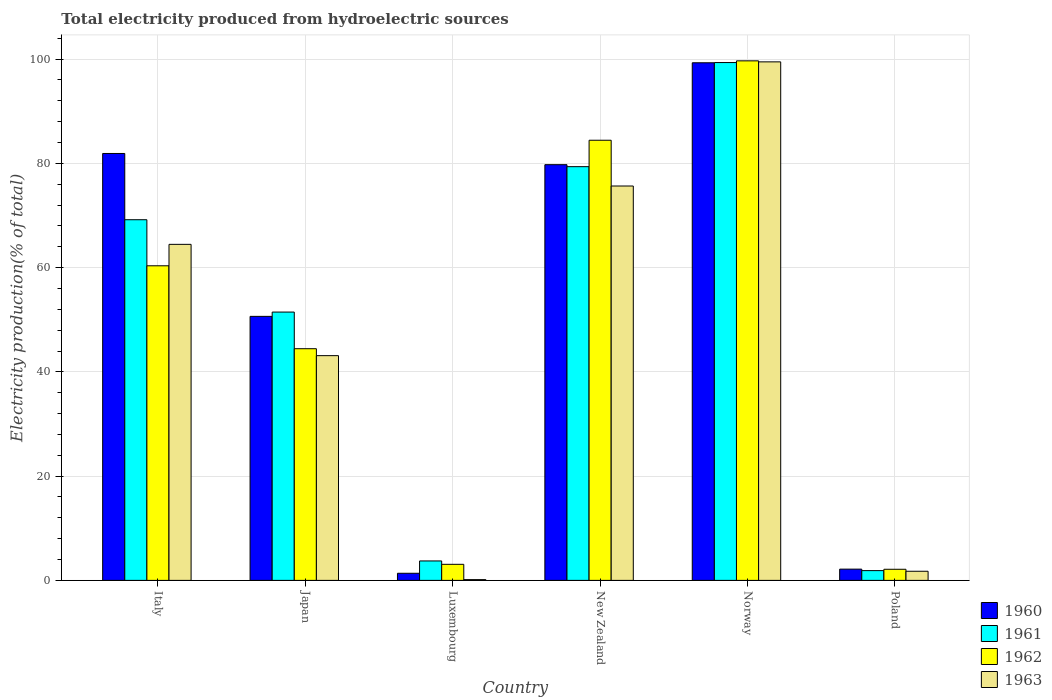How many different coloured bars are there?
Make the answer very short. 4. Are the number of bars per tick equal to the number of legend labels?
Your answer should be compact. Yes. How many bars are there on the 6th tick from the left?
Your response must be concise. 4. What is the label of the 6th group of bars from the left?
Offer a very short reply. Poland. What is the total electricity produced in 1960 in Japan?
Your answer should be very brief. 50.65. Across all countries, what is the maximum total electricity produced in 1961?
Offer a terse response. 99.34. Across all countries, what is the minimum total electricity produced in 1961?
Keep it short and to the point. 1.87. In which country was the total electricity produced in 1961 maximum?
Your answer should be compact. Norway. In which country was the total electricity produced in 1963 minimum?
Your answer should be compact. Luxembourg. What is the total total electricity produced in 1961 in the graph?
Your response must be concise. 304.98. What is the difference between the total electricity produced in 1962 in Japan and that in New Zealand?
Offer a very short reply. -39.99. What is the difference between the total electricity produced in 1960 in Luxembourg and the total electricity produced in 1962 in New Zealand?
Keep it short and to the point. -83.07. What is the average total electricity produced in 1963 per country?
Keep it short and to the point. 47.44. What is the difference between the total electricity produced of/in 1960 and total electricity produced of/in 1962 in Italy?
Offer a very short reply. 21.55. In how many countries, is the total electricity produced in 1962 greater than 88 %?
Keep it short and to the point. 1. What is the ratio of the total electricity produced in 1963 in Luxembourg to that in Norway?
Your response must be concise. 0. Is the total electricity produced in 1962 in Luxembourg less than that in Poland?
Offer a very short reply. No. Is the difference between the total electricity produced in 1960 in Luxembourg and Norway greater than the difference between the total electricity produced in 1962 in Luxembourg and Norway?
Offer a terse response. No. What is the difference between the highest and the second highest total electricity produced in 1962?
Ensure brevity in your answer.  15.23. What is the difference between the highest and the lowest total electricity produced in 1963?
Your answer should be very brief. 99.33. In how many countries, is the total electricity produced in 1962 greater than the average total electricity produced in 1962 taken over all countries?
Offer a terse response. 3. Is the sum of the total electricity produced in 1962 in Luxembourg and Poland greater than the maximum total electricity produced in 1961 across all countries?
Ensure brevity in your answer.  No. What does the 4th bar from the left in Italy represents?
Your answer should be compact. 1963. What does the 2nd bar from the right in New Zealand represents?
Your answer should be compact. 1962. Are all the bars in the graph horizontal?
Give a very brief answer. No. How many countries are there in the graph?
Your answer should be compact. 6. What is the difference between two consecutive major ticks on the Y-axis?
Offer a very short reply. 20. Are the values on the major ticks of Y-axis written in scientific E-notation?
Offer a terse response. No. Where does the legend appear in the graph?
Keep it short and to the point. Bottom right. What is the title of the graph?
Provide a short and direct response. Total electricity produced from hydroelectric sources. What is the label or title of the X-axis?
Provide a succinct answer. Country. What is the Electricity production(% of total) in 1960 in Italy?
Your answer should be very brief. 81.9. What is the Electricity production(% of total) of 1961 in Italy?
Provide a succinct answer. 69.19. What is the Electricity production(% of total) of 1962 in Italy?
Your response must be concise. 60.35. What is the Electricity production(% of total) in 1963 in Italy?
Your answer should be compact. 64.47. What is the Electricity production(% of total) of 1960 in Japan?
Ensure brevity in your answer.  50.65. What is the Electricity production(% of total) in 1961 in Japan?
Provide a short and direct response. 51.48. What is the Electricity production(% of total) of 1962 in Japan?
Make the answer very short. 44.44. What is the Electricity production(% of total) in 1963 in Japan?
Keep it short and to the point. 43.11. What is the Electricity production(% of total) in 1960 in Luxembourg?
Your response must be concise. 1.37. What is the Electricity production(% of total) in 1961 in Luxembourg?
Your answer should be compact. 3.73. What is the Electricity production(% of total) of 1962 in Luxembourg?
Your answer should be very brief. 3.08. What is the Electricity production(% of total) of 1963 in Luxembourg?
Your answer should be compact. 0.15. What is the Electricity production(% of total) of 1960 in New Zealand?
Keep it short and to the point. 79.75. What is the Electricity production(% of total) of 1961 in New Zealand?
Ensure brevity in your answer.  79.37. What is the Electricity production(% of total) of 1962 in New Zealand?
Ensure brevity in your answer.  84.44. What is the Electricity production(% of total) of 1963 in New Zealand?
Provide a succinct answer. 75.66. What is the Electricity production(% of total) in 1960 in Norway?
Offer a terse response. 99.3. What is the Electricity production(% of total) of 1961 in Norway?
Offer a terse response. 99.34. What is the Electricity production(% of total) in 1962 in Norway?
Offer a terse response. 99.67. What is the Electricity production(% of total) of 1963 in Norway?
Your answer should be compact. 99.47. What is the Electricity production(% of total) of 1960 in Poland?
Offer a terse response. 2.16. What is the Electricity production(% of total) in 1961 in Poland?
Make the answer very short. 1.87. What is the Electricity production(% of total) in 1962 in Poland?
Your answer should be compact. 2.13. What is the Electricity production(% of total) in 1963 in Poland?
Keep it short and to the point. 1.75. Across all countries, what is the maximum Electricity production(% of total) of 1960?
Ensure brevity in your answer.  99.3. Across all countries, what is the maximum Electricity production(% of total) in 1961?
Give a very brief answer. 99.34. Across all countries, what is the maximum Electricity production(% of total) in 1962?
Ensure brevity in your answer.  99.67. Across all countries, what is the maximum Electricity production(% of total) in 1963?
Keep it short and to the point. 99.47. Across all countries, what is the minimum Electricity production(% of total) of 1960?
Provide a short and direct response. 1.37. Across all countries, what is the minimum Electricity production(% of total) of 1961?
Keep it short and to the point. 1.87. Across all countries, what is the minimum Electricity production(% of total) of 1962?
Provide a short and direct response. 2.13. Across all countries, what is the minimum Electricity production(% of total) in 1963?
Ensure brevity in your answer.  0.15. What is the total Electricity production(% of total) of 1960 in the graph?
Provide a succinct answer. 315.13. What is the total Electricity production(% of total) in 1961 in the graph?
Give a very brief answer. 304.98. What is the total Electricity production(% of total) in 1962 in the graph?
Give a very brief answer. 294.12. What is the total Electricity production(% of total) in 1963 in the graph?
Give a very brief answer. 284.61. What is the difference between the Electricity production(% of total) in 1960 in Italy and that in Japan?
Your response must be concise. 31.25. What is the difference between the Electricity production(% of total) in 1961 in Italy and that in Japan?
Offer a terse response. 17.71. What is the difference between the Electricity production(% of total) in 1962 in Italy and that in Japan?
Keep it short and to the point. 15.91. What is the difference between the Electricity production(% of total) in 1963 in Italy and that in Japan?
Make the answer very short. 21.35. What is the difference between the Electricity production(% of total) of 1960 in Italy and that in Luxembourg?
Offer a terse response. 80.53. What is the difference between the Electricity production(% of total) of 1961 in Italy and that in Luxembourg?
Ensure brevity in your answer.  65.46. What is the difference between the Electricity production(% of total) in 1962 in Italy and that in Luxembourg?
Give a very brief answer. 57.27. What is the difference between the Electricity production(% of total) in 1963 in Italy and that in Luxembourg?
Provide a short and direct response. 64.32. What is the difference between the Electricity production(% of total) in 1960 in Italy and that in New Zealand?
Offer a terse response. 2.15. What is the difference between the Electricity production(% of total) in 1961 in Italy and that in New Zealand?
Provide a short and direct response. -10.18. What is the difference between the Electricity production(% of total) of 1962 in Italy and that in New Zealand?
Provide a succinct answer. -24.08. What is the difference between the Electricity production(% of total) of 1963 in Italy and that in New Zealand?
Provide a short and direct response. -11.19. What is the difference between the Electricity production(% of total) in 1960 in Italy and that in Norway?
Give a very brief answer. -17.4. What is the difference between the Electricity production(% of total) of 1961 in Italy and that in Norway?
Your answer should be very brief. -30.15. What is the difference between the Electricity production(% of total) of 1962 in Italy and that in Norway?
Your response must be concise. -39.32. What is the difference between the Electricity production(% of total) in 1963 in Italy and that in Norway?
Ensure brevity in your answer.  -35.01. What is the difference between the Electricity production(% of total) in 1960 in Italy and that in Poland?
Your answer should be very brief. 79.74. What is the difference between the Electricity production(% of total) in 1961 in Italy and that in Poland?
Your answer should be compact. 67.32. What is the difference between the Electricity production(% of total) in 1962 in Italy and that in Poland?
Your answer should be very brief. 58.22. What is the difference between the Electricity production(% of total) of 1963 in Italy and that in Poland?
Ensure brevity in your answer.  62.72. What is the difference between the Electricity production(% of total) of 1960 in Japan and that in Luxembourg?
Your response must be concise. 49.28. What is the difference between the Electricity production(% of total) in 1961 in Japan and that in Luxembourg?
Your answer should be compact. 47.75. What is the difference between the Electricity production(% of total) of 1962 in Japan and that in Luxembourg?
Ensure brevity in your answer.  41.36. What is the difference between the Electricity production(% of total) of 1963 in Japan and that in Luxembourg?
Offer a very short reply. 42.97. What is the difference between the Electricity production(% of total) of 1960 in Japan and that in New Zealand?
Ensure brevity in your answer.  -29.1. What is the difference between the Electricity production(% of total) in 1961 in Japan and that in New Zealand?
Offer a terse response. -27.9. What is the difference between the Electricity production(% of total) in 1962 in Japan and that in New Zealand?
Offer a terse response. -39.99. What is the difference between the Electricity production(% of total) in 1963 in Japan and that in New Zealand?
Your answer should be very brief. -32.54. What is the difference between the Electricity production(% of total) of 1960 in Japan and that in Norway?
Your response must be concise. -48.65. What is the difference between the Electricity production(% of total) of 1961 in Japan and that in Norway?
Give a very brief answer. -47.87. What is the difference between the Electricity production(% of total) of 1962 in Japan and that in Norway?
Ensure brevity in your answer.  -55.23. What is the difference between the Electricity production(% of total) of 1963 in Japan and that in Norway?
Keep it short and to the point. -56.36. What is the difference between the Electricity production(% of total) in 1960 in Japan and that in Poland?
Offer a terse response. 48.49. What is the difference between the Electricity production(% of total) in 1961 in Japan and that in Poland?
Your answer should be compact. 49.6. What is the difference between the Electricity production(% of total) in 1962 in Japan and that in Poland?
Ensure brevity in your answer.  42.31. What is the difference between the Electricity production(% of total) in 1963 in Japan and that in Poland?
Your response must be concise. 41.36. What is the difference between the Electricity production(% of total) of 1960 in Luxembourg and that in New Zealand?
Provide a short and direct response. -78.38. What is the difference between the Electricity production(% of total) in 1961 in Luxembourg and that in New Zealand?
Provide a succinct answer. -75.64. What is the difference between the Electricity production(% of total) of 1962 in Luxembourg and that in New Zealand?
Ensure brevity in your answer.  -81.36. What is the difference between the Electricity production(% of total) of 1963 in Luxembourg and that in New Zealand?
Give a very brief answer. -75.51. What is the difference between the Electricity production(% of total) in 1960 in Luxembourg and that in Norway?
Ensure brevity in your answer.  -97.93. What is the difference between the Electricity production(% of total) in 1961 in Luxembourg and that in Norway?
Provide a short and direct response. -95.61. What is the difference between the Electricity production(% of total) in 1962 in Luxembourg and that in Norway?
Ensure brevity in your answer.  -96.59. What is the difference between the Electricity production(% of total) of 1963 in Luxembourg and that in Norway?
Make the answer very short. -99.33. What is the difference between the Electricity production(% of total) in 1960 in Luxembourg and that in Poland?
Provide a succinct answer. -0.79. What is the difference between the Electricity production(% of total) of 1961 in Luxembourg and that in Poland?
Your response must be concise. 1.86. What is the difference between the Electricity production(% of total) of 1962 in Luxembourg and that in Poland?
Your response must be concise. 0.95. What is the difference between the Electricity production(% of total) in 1963 in Luxembourg and that in Poland?
Your response must be concise. -1.6. What is the difference between the Electricity production(% of total) of 1960 in New Zealand and that in Norway?
Make the answer very short. -19.55. What is the difference between the Electricity production(% of total) in 1961 in New Zealand and that in Norway?
Offer a very short reply. -19.97. What is the difference between the Electricity production(% of total) in 1962 in New Zealand and that in Norway?
Give a very brief answer. -15.23. What is the difference between the Electricity production(% of total) of 1963 in New Zealand and that in Norway?
Make the answer very short. -23.82. What is the difference between the Electricity production(% of total) of 1960 in New Zealand and that in Poland?
Keep it short and to the point. 77.59. What is the difference between the Electricity production(% of total) in 1961 in New Zealand and that in Poland?
Your answer should be compact. 77.5. What is the difference between the Electricity production(% of total) of 1962 in New Zealand and that in Poland?
Your answer should be very brief. 82.31. What is the difference between the Electricity production(% of total) in 1963 in New Zealand and that in Poland?
Offer a very short reply. 73.91. What is the difference between the Electricity production(% of total) of 1960 in Norway and that in Poland?
Your answer should be very brief. 97.14. What is the difference between the Electricity production(% of total) of 1961 in Norway and that in Poland?
Provide a succinct answer. 97.47. What is the difference between the Electricity production(% of total) in 1962 in Norway and that in Poland?
Your answer should be very brief. 97.54. What is the difference between the Electricity production(% of total) of 1963 in Norway and that in Poland?
Offer a terse response. 97.72. What is the difference between the Electricity production(% of total) in 1960 in Italy and the Electricity production(% of total) in 1961 in Japan?
Provide a short and direct response. 30.42. What is the difference between the Electricity production(% of total) of 1960 in Italy and the Electricity production(% of total) of 1962 in Japan?
Ensure brevity in your answer.  37.46. What is the difference between the Electricity production(% of total) in 1960 in Italy and the Electricity production(% of total) in 1963 in Japan?
Your answer should be compact. 38.79. What is the difference between the Electricity production(% of total) of 1961 in Italy and the Electricity production(% of total) of 1962 in Japan?
Provide a short and direct response. 24.75. What is the difference between the Electricity production(% of total) in 1961 in Italy and the Electricity production(% of total) in 1963 in Japan?
Offer a terse response. 26.08. What is the difference between the Electricity production(% of total) in 1962 in Italy and the Electricity production(% of total) in 1963 in Japan?
Offer a very short reply. 17.24. What is the difference between the Electricity production(% of total) of 1960 in Italy and the Electricity production(% of total) of 1961 in Luxembourg?
Provide a short and direct response. 78.17. What is the difference between the Electricity production(% of total) in 1960 in Italy and the Electricity production(% of total) in 1962 in Luxembourg?
Give a very brief answer. 78.82. What is the difference between the Electricity production(% of total) in 1960 in Italy and the Electricity production(% of total) in 1963 in Luxembourg?
Your response must be concise. 81.75. What is the difference between the Electricity production(% of total) in 1961 in Italy and the Electricity production(% of total) in 1962 in Luxembourg?
Your response must be concise. 66.11. What is the difference between the Electricity production(% of total) of 1961 in Italy and the Electricity production(% of total) of 1963 in Luxembourg?
Your answer should be very brief. 69.04. What is the difference between the Electricity production(% of total) in 1962 in Italy and the Electricity production(% of total) in 1963 in Luxembourg?
Provide a short and direct response. 60.21. What is the difference between the Electricity production(% of total) of 1960 in Italy and the Electricity production(% of total) of 1961 in New Zealand?
Offer a very short reply. 2.53. What is the difference between the Electricity production(% of total) in 1960 in Italy and the Electricity production(% of total) in 1962 in New Zealand?
Offer a very short reply. -2.54. What is the difference between the Electricity production(% of total) in 1960 in Italy and the Electricity production(% of total) in 1963 in New Zealand?
Offer a terse response. 6.24. What is the difference between the Electricity production(% of total) in 1961 in Italy and the Electricity production(% of total) in 1962 in New Zealand?
Your response must be concise. -15.25. What is the difference between the Electricity production(% of total) in 1961 in Italy and the Electricity production(% of total) in 1963 in New Zealand?
Provide a short and direct response. -6.47. What is the difference between the Electricity production(% of total) in 1962 in Italy and the Electricity production(% of total) in 1963 in New Zealand?
Your answer should be very brief. -15.3. What is the difference between the Electricity production(% of total) in 1960 in Italy and the Electricity production(% of total) in 1961 in Norway?
Your answer should be compact. -17.44. What is the difference between the Electricity production(% of total) of 1960 in Italy and the Electricity production(% of total) of 1962 in Norway?
Your response must be concise. -17.77. What is the difference between the Electricity production(% of total) of 1960 in Italy and the Electricity production(% of total) of 1963 in Norway?
Your answer should be compact. -17.57. What is the difference between the Electricity production(% of total) of 1961 in Italy and the Electricity production(% of total) of 1962 in Norway?
Keep it short and to the point. -30.48. What is the difference between the Electricity production(% of total) in 1961 in Italy and the Electricity production(% of total) in 1963 in Norway?
Offer a terse response. -30.28. What is the difference between the Electricity production(% of total) in 1962 in Italy and the Electricity production(% of total) in 1963 in Norway?
Keep it short and to the point. -39.12. What is the difference between the Electricity production(% of total) of 1960 in Italy and the Electricity production(% of total) of 1961 in Poland?
Offer a very short reply. 80.03. What is the difference between the Electricity production(% of total) of 1960 in Italy and the Electricity production(% of total) of 1962 in Poland?
Your answer should be very brief. 79.77. What is the difference between the Electricity production(% of total) in 1960 in Italy and the Electricity production(% of total) in 1963 in Poland?
Give a very brief answer. 80.15. What is the difference between the Electricity production(% of total) in 1961 in Italy and the Electricity production(% of total) in 1962 in Poland?
Provide a short and direct response. 67.06. What is the difference between the Electricity production(% of total) in 1961 in Italy and the Electricity production(% of total) in 1963 in Poland?
Provide a succinct answer. 67.44. What is the difference between the Electricity production(% of total) of 1962 in Italy and the Electricity production(% of total) of 1963 in Poland?
Your answer should be compact. 58.6. What is the difference between the Electricity production(% of total) of 1960 in Japan and the Electricity production(% of total) of 1961 in Luxembourg?
Give a very brief answer. 46.92. What is the difference between the Electricity production(% of total) of 1960 in Japan and the Electricity production(% of total) of 1962 in Luxembourg?
Your answer should be compact. 47.57. What is the difference between the Electricity production(% of total) of 1960 in Japan and the Electricity production(% of total) of 1963 in Luxembourg?
Provide a short and direct response. 50.5. What is the difference between the Electricity production(% of total) of 1961 in Japan and the Electricity production(% of total) of 1962 in Luxembourg?
Your answer should be compact. 48.39. What is the difference between the Electricity production(% of total) of 1961 in Japan and the Electricity production(% of total) of 1963 in Luxembourg?
Your response must be concise. 51.33. What is the difference between the Electricity production(% of total) in 1962 in Japan and the Electricity production(% of total) in 1963 in Luxembourg?
Ensure brevity in your answer.  44.3. What is the difference between the Electricity production(% of total) of 1960 in Japan and the Electricity production(% of total) of 1961 in New Zealand?
Your answer should be compact. -28.72. What is the difference between the Electricity production(% of total) in 1960 in Japan and the Electricity production(% of total) in 1962 in New Zealand?
Offer a terse response. -33.79. What is the difference between the Electricity production(% of total) of 1960 in Japan and the Electricity production(% of total) of 1963 in New Zealand?
Offer a terse response. -25.01. What is the difference between the Electricity production(% of total) in 1961 in Japan and the Electricity production(% of total) in 1962 in New Zealand?
Ensure brevity in your answer.  -32.96. What is the difference between the Electricity production(% of total) in 1961 in Japan and the Electricity production(% of total) in 1963 in New Zealand?
Your answer should be compact. -24.18. What is the difference between the Electricity production(% of total) in 1962 in Japan and the Electricity production(% of total) in 1963 in New Zealand?
Your answer should be compact. -31.21. What is the difference between the Electricity production(% of total) in 1960 in Japan and the Electricity production(% of total) in 1961 in Norway?
Keep it short and to the point. -48.69. What is the difference between the Electricity production(% of total) of 1960 in Japan and the Electricity production(% of total) of 1962 in Norway?
Offer a very short reply. -49.02. What is the difference between the Electricity production(% of total) of 1960 in Japan and the Electricity production(% of total) of 1963 in Norway?
Provide a short and direct response. -48.83. What is the difference between the Electricity production(% of total) of 1961 in Japan and the Electricity production(% of total) of 1962 in Norway?
Ensure brevity in your answer.  -48.19. What is the difference between the Electricity production(% of total) in 1961 in Japan and the Electricity production(% of total) in 1963 in Norway?
Your answer should be compact. -48. What is the difference between the Electricity production(% of total) in 1962 in Japan and the Electricity production(% of total) in 1963 in Norway?
Your response must be concise. -55.03. What is the difference between the Electricity production(% of total) in 1960 in Japan and the Electricity production(% of total) in 1961 in Poland?
Give a very brief answer. 48.78. What is the difference between the Electricity production(% of total) of 1960 in Japan and the Electricity production(% of total) of 1962 in Poland?
Provide a short and direct response. 48.52. What is the difference between the Electricity production(% of total) in 1960 in Japan and the Electricity production(% of total) in 1963 in Poland?
Make the answer very short. 48.9. What is the difference between the Electricity production(% of total) in 1961 in Japan and the Electricity production(% of total) in 1962 in Poland?
Offer a very short reply. 49.34. What is the difference between the Electricity production(% of total) in 1961 in Japan and the Electricity production(% of total) in 1963 in Poland?
Provide a succinct answer. 49.72. What is the difference between the Electricity production(% of total) of 1962 in Japan and the Electricity production(% of total) of 1963 in Poland?
Your answer should be compact. 42.69. What is the difference between the Electricity production(% of total) in 1960 in Luxembourg and the Electricity production(% of total) in 1961 in New Zealand?
Keep it short and to the point. -78.01. What is the difference between the Electricity production(% of total) in 1960 in Luxembourg and the Electricity production(% of total) in 1962 in New Zealand?
Offer a terse response. -83.07. What is the difference between the Electricity production(% of total) in 1960 in Luxembourg and the Electricity production(% of total) in 1963 in New Zealand?
Make the answer very short. -74.29. What is the difference between the Electricity production(% of total) of 1961 in Luxembourg and the Electricity production(% of total) of 1962 in New Zealand?
Provide a short and direct response. -80.71. What is the difference between the Electricity production(% of total) in 1961 in Luxembourg and the Electricity production(% of total) in 1963 in New Zealand?
Your answer should be compact. -71.93. What is the difference between the Electricity production(% of total) of 1962 in Luxembourg and the Electricity production(% of total) of 1963 in New Zealand?
Make the answer very short. -72.58. What is the difference between the Electricity production(% of total) of 1960 in Luxembourg and the Electricity production(% of total) of 1961 in Norway?
Offer a very short reply. -97.98. What is the difference between the Electricity production(% of total) in 1960 in Luxembourg and the Electricity production(% of total) in 1962 in Norway?
Offer a terse response. -98.3. What is the difference between the Electricity production(% of total) in 1960 in Luxembourg and the Electricity production(% of total) in 1963 in Norway?
Offer a terse response. -98.11. What is the difference between the Electricity production(% of total) of 1961 in Luxembourg and the Electricity production(% of total) of 1962 in Norway?
Provide a short and direct response. -95.94. What is the difference between the Electricity production(% of total) in 1961 in Luxembourg and the Electricity production(% of total) in 1963 in Norway?
Give a very brief answer. -95.74. What is the difference between the Electricity production(% of total) in 1962 in Luxembourg and the Electricity production(% of total) in 1963 in Norway?
Make the answer very short. -96.39. What is the difference between the Electricity production(% of total) of 1960 in Luxembourg and the Electricity production(% of total) of 1961 in Poland?
Provide a succinct answer. -0.51. What is the difference between the Electricity production(% of total) of 1960 in Luxembourg and the Electricity production(% of total) of 1962 in Poland?
Provide a succinct answer. -0.77. What is the difference between the Electricity production(% of total) of 1960 in Luxembourg and the Electricity production(% of total) of 1963 in Poland?
Keep it short and to the point. -0.39. What is the difference between the Electricity production(% of total) of 1961 in Luxembourg and the Electricity production(% of total) of 1962 in Poland?
Your answer should be compact. 1.6. What is the difference between the Electricity production(% of total) of 1961 in Luxembourg and the Electricity production(% of total) of 1963 in Poland?
Keep it short and to the point. 1.98. What is the difference between the Electricity production(% of total) of 1962 in Luxembourg and the Electricity production(% of total) of 1963 in Poland?
Provide a succinct answer. 1.33. What is the difference between the Electricity production(% of total) of 1960 in New Zealand and the Electricity production(% of total) of 1961 in Norway?
Offer a terse response. -19.59. What is the difference between the Electricity production(% of total) in 1960 in New Zealand and the Electricity production(% of total) in 1962 in Norway?
Give a very brief answer. -19.92. What is the difference between the Electricity production(% of total) of 1960 in New Zealand and the Electricity production(% of total) of 1963 in Norway?
Make the answer very short. -19.72. What is the difference between the Electricity production(% of total) of 1961 in New Zealand and the Electricity production(% of total) of 1962 in Norway?
Your answer should be compact. -20.3. What is the difference between the Electricity production(% of total) in 1961 in New Zealand and the Electricity production(% of total) in 1963 in Norway?
Provide a short and direct response. -20.1. What is the difference between the Electricity production(% of total) in 1962 in New Zealand and the Electricity production(% of total) in 1963 in Norway?
Offer a terse response. -15.04. What is the difference between the Electricity production(% of total) of 1960 in New Zealand and the Electricity production(% of total) of 1961 in Poland?
Keep it short and to the point. 77.88. What is the difference between the Electricity production(% of total) of 1960 in New Zealand and the Electricity production(% of total) of 1962 in Poland?
Provide a short and direct response. 77.62. What is the difference between the Electricity production(% of total) in 1960 in New Zealand and the Electricity production(% of total) in 1963 in Poland?
Your answer should be very brief. 78. What is the difference between the Electricity production(% of total) in 1961 in New Zealand and the Electricity production(% of total) in 1962 in Poland?
Provide a short and direct response. 77.24. What is the difference between the Electricity production(% of total) in 1961 in New Zealand and the Electricity production(% of total) in 1963 in Poland?
Provide a short and direct response. 77.62. What is the difference between the Electricity production(% of total) in 1962 in New Zealand and the Electricity production(% of total) in 1963 in Poland?
Ensure brevity in your answer.  82.69. What is the difference between the Electricity production(% of total) in 1960 in Norway and the Electricity production(% of total) in 1961 in Poland?
Your answer should be very brief. 97.43. What is the difference between the Electricity production(% of total) in 1960 in Norway and the Electricity production(% of total) in 1962 in Poland?
Keep it short and to the point. 97.17. What is the difference between the Electricity production(% of total) in 1960 in Norway and the Electricity production(% of total) in 1963 in Poland?
Keep it short and to the point. 97.55. What is the difference between the Electricity production(% of total) of 1961 in Norway and the Electricity production(% of total) of 1962 in Poland?
Your response must be concise. 97.21. What is the difference between the Electricity production(% of total) in 1961 in Norway and the Electricity production(% of total) in 1963 in Poland?
Your answer should be very brief. 97.59. What is the difference between the Electricity production(% of total) in 1962 in Norway and the Electricity production(% of total) in 1963 in Poland?
Your response must be concise. 97.92. What is the average Electricity production(% of total) in 1960 per country?
Your response must be concise. 52.52. What is the average Electricity production(% of total) of 1961 per country?
Ensure brevity in your answer.  50.83. What is the average Electricity production(% of total) in 1962 per country?
Provide a succinct answer. 49.02. What is the average Electricity production(% of total) in 1963 per country?
Ensure brevity in your answer.  47.44. What is the difference between the Electricity production(% of total) in 1960 and Electricity production(% of total) in 1961 in Italy?
Provide a short and direct response. 12.71. What is the difference between the Electricity production(% of total) in 1960 and Electricity production(% of total) in 1962 in Italy?
Offer a very short reply. 21.55. What is the difference between the Electricity production(% of total) in 1960 and Electricity production(% of total) in 1963 in Italy?
Provide a succinct answer. 17.43. What is the difference between the Electricity production(% of total) in 1961 and Electricity production(% of total) in 1962 in Italy?
Keep it short and to the point. 8.84. What is the difference between the Electricity production(% of total) in 1961 and Electricity production(% of total) in 1963 in Italy?
Give a very brief answer. 4.72. What is the difference between the Electricity production(% of total) in 1962 and Electricity production(% of total) in 1963 in Italy?
Keep it short and to the point. -4.11. What is the difference between the Electricity production(% of total) in 1960 and Electricity production(% of total) in 1961 in Japan?
Keep it short and to the point. -0.83. What is the difference between the Electricity production(% of total) in 1960 and Electricity production(% of total) in 1962 in Japan?
Offer a very short reply. 6.2. What is the difference between the Electricity production(% of total) in 1960 and Electricity production(% of total) in 1963 in Japan?
Your answer should be very brief. 7.54. What is the difference between the Electricity production(% of total) in 1961 and Electricity production(% of total) in 1962 in Japan?
Ensure brevity in your answer.  7.03. What is the difference between the Electricity production(% of total) in 1961 and Electricity production(% of total) in 1963 in Japan?
Give a very brief answer. 8.36. What is the difference between the Electricity production(% of total) of 1962 and Electricity production(% of total) of 1963 in Japan?
Your answer should be very brief. 1.33. What is the difference between the Electricity production(% of total) of 1960 and Electricity production(% of total) of 1961 in Luxembourg?
Your answer should be compact. -2.36. What is the difference between the Electricity production(% of total) of 1960 and Electricity production(% of total) of 1962 in Luxembourg?
Make the answer very short. -1.72. What is the difference between the Electricity production(% of total) in 1960 and Electricity production(% of total) in 1963 in Luxembourg?
Your answer should be very brief. 1.22. What is the difference between the Electricity production(% of total) of 1961 and Electricity production(% of total) of 1962 in Luxembourg?
Give a very brief answer. 0.65. What is the difference between the Electricity production(% of total) in 1961 and Electricity production(% of total) in 1963 in Luxembourg?
Provide a short and direct response. 3.58. What is the difference between the Electricity production(% of total) of 1962 and Electricity production(% of total) of 1963 in Luxembourg?
Provide a succinct answer. 2.93. What is the difference between the Electricity production(% of total) of 1960 and Electricity production(% of total) of 1961 in New Zealand?
Your response must be concise. 0.38. What is the difference between the Electricity production(% of total) in 1960 and Electricity production(% of total) in 1962 in New Zealand?
Your answer should be very brief. -4.69. What is the difference between the Electricity production(% of total) of 1960 and Electricity production(% of total) of 1963 in New Zealand?
Provide a short and direct response. 4.09. What is the difference between the Electricity production(% of total) of 1961 and Electricity production(% of total) of 1962 in New Zealand?
Give a very brief answer. -5.07. What is the difference between the Electricity production(% of total) in 1961 and Electricity production(% of total) in 1963 in New Zealand?
Ensure brevity in your answer.  3.71. What is the difference between the Electricity production(% of total) of 1962 and Electricity production(% of total) of 1963 in New Zealand?
Give a very brief answer. 8.78. What is the difference between the Electricity production(% of total) in 1960 and Electricity production(% of total) in 1961 in Norway?
Ensure brevity in your answer.  -0.04. What is the difference between the Electricity production(% of total) in 1960 and Electricity production(% of total) in 1962 in Norway?
Your response must be concise. -0.37. What is the difference between the Electricity production(% of total) in 1960 and Electricity production(% of total) in 1963 in Norway?
Your answer should be very brief. -0.17. What is the difference between the Electricity production(% of total) of 1961 and Electricity production(% of total) of 1962 in Norway?
Ensure brevity in your answer.  -0.33. What is the difference between the Electricity production(% of total) of 1961 and Electricity production(% of total) of 1963 in Norway?
Keep it short and to the point. -0.13. What is the difference between the Electricity production(% of total) of 1962 and Electricity production(% of total) of 1963 in Norway?
Make the answer very short. 0.19. What is the difference between the Electricity production(% of total) of 1960 and Electricity production(% of total) of 1961 in Poland?
Make the answer very short. 0.28. What is the difference between the Electricity production(% of total) of 1960 and Electricity production(% of total) of 1962 in Poland?
Provide a succinct answer. 0.03. What is the difference between the Electricity production(% of total) in 1960 and Electricity production(% of total) in 1963 in Poland?
Your answer should be compact. 0.41. What is the difference between the Electricity production(% of total) in 1961 and Electricity production(% of total) in 1962 in Poland?
Make the answer very short. -0.26. What is the difference between the Electricity production(% of total) of 1961 and Electricity production(% of total) of 1963 in Poland?
Offer a very short reply. 0.12. What is the difference between the Electricity production(% of total) of 1962 and Electricity production(% of total) of 1963 in Poland?
Your answer should be very brief. 0.38. What is the ratio of the Electricity production(% of total) in 1960 in Italy to that in Japan?
Your answer should be compact. 1.62. What is the ratio of the Electricity production(% of total) of 1961 in Italy to that in Japan?
Offer a terse response. 1.34. What is the ratio of the Electricity production(% of total) of 1962 in Italy to that in Japan?
Keep it short and to the point. 1.36. What is the ratio of the Electricity production(% of total) in 1963 in Italy to that in Japan?
Your answer should be very brief. 1.5. What is the ratio of the Electricity production(% of total) of 1960 in Italy to that in Luxembourg?
Your answer should be compact. 59.95. What is the ratio of the Electricity production(% of total) in 1961 in Italy to that in Luxembourg?
Your response must be concise. 18.55. What is the ratio of the Electricity production(% of total) of 1962 in Italy to that in Luxembourg?
Your response must be concise. 19.58. What is the ratio of the Electricity production(% of total) of 1963 in Italy to that in Luxembourg?
Your answer should be very brief. 436.77. What is the ratio of the Electricity production(% of total) in 1961 in Italy to that in New Zealand?
Your response must be concise. 0.87. What is the ratio of the Electricity production(% of total) in 1962 in Italy to that in New Zealand?
Offer a very short reply. 0.71. What is the ratio of the Electricity production(% of total) in 1963 in Italy to that in New Zealand?
Your answer should be very brief. 0.85. What is the ratio of the Electricity production(% of total) of 1960 in Italy to that in Norway?
Ensure brevity in your answer.  0.82. What is the ratio of the Electricity production(% of total) in 1961 in Italy to that in Norway?
Ensure brevity in your answer.  0.7. What is the ratio of the Electricity production(% of total) of 1962 in Italy to that in Norway?
Provide a short and direct response. 0.61. What is the ratio of the Electricity production(% of total) in 1963 in Italy to that in Norway?
Your answer should be very brief. 0.65. What is the ratio of the Electricity production(% of total) of 1960 in Italy to that in Poland?
Offer a very short reply. 37.95. What is the ratio of the Electricity production(% of total) of 1961 in Italy to that in Poland?
Ensure brevity in your answer.  36.93. What is the ratio of the Electricity production(% of total) in 1962 in Italy to that in Poland?
Offer a very short reply. 28.31. What is the ratio of the Electricity production(% of total) of 1963 in Italy to that in Poland?
Your answer should be very brief. 36.81. What is the ratio of the Electricity production(% of total) of 1960 in Japan to that in Luxembourg?
Your answer should be very brief. 37.08. What is the ratio of the Electricity production(% of total) of 1961 in Japan to that in Luxembourg?
Your answer should be compact. 13.8. What is the ratio of the Electricity production(% of total) in 1962 in Japan to that in Luxembourg?
Make the answer very short. 14.42. What is the ratio of the Electricity production(% of total) in 1963 in Japan to that in Luxembourg?
Make the answer very short. 292.1. What is the ratio of the Electricity production(% of total) of 1960 in Japan to that in New Zealand?
Your answer should be compact. 0.64. What is the ratio of the Electricity production(% of total) in 1961 in Japan to that in New Zealand?
Offer a very short reply. 0.65. What is the ratio of the Electricity production(% of total) of 1962 in Japan to that in New Zealand?
Offer a very short reply. 0.53. What is the ratio of the Electricity production(% of total) of 1963 in Japan to that in New Zealand?
Give a very brief answer. 0.57. What is the ratio of the Electricity production(% of total) of 1960 in Japan to that in Norway?
Your answer should be compact. 0.51. What is the ratio of the Electricity production(% of total) of 1961 in Japan to that in Norway?
Offer a terse response. 0.52. What is the ratio of the Electricity production(% of total) in 1962 in Japan to that in Norway?
Your response must be concise. 0.45. What is the ratio of the Electricity production(% of total) in 1963 in Japan to that in Norway?
Your answer should be compact. 0.43. What is the ratio of the Electricity production(% of total) in 1960 in Japan to that in Poland?
Ensure brevity in your answer.  23.47. What is the ratio of the Electricity production(% of total) in 1961 in Japan to that in Poland?
Ensure brevity in your answer.  27.48. What is the ratio of the Electricity production(% of total) of 1962 in Japan to that in Poland?
Make the answer very short. 20.85. What is the ratio of the Electricity production(% of total) in 1963 in Japan to that in Poland?
Your response must be concise. 24.62. What is the ratio of the Electricity production(% of total) in 1960 in Luxembourg to that in New Zealand?
Offer a terse response. 0.02. What is the ratio of the Electricity production(% of total) in 1961 in Luxembourg to that in New Zealand?
Provide a short and direct response. 0.05. What is the ratio of the Electricity production(% of total) of 1962 in Luxembourg to that in New Zealand?
Make the answer very short. 0.04. What is the ratio of the Electricity production(% of total) in 1963 in Luxembourg to that in New Zealand?
Provide a short and direct response. 0. What is the ratio of the Electricity production(% of total) in 1960 in Luxembourg to that in Norway?
Provide a succinct answer. 0.01. What is the ratio of the Electricity production(% of total) in 1961 in Luxembourg to that in Norway?
Make the answer very short. 0.04. What is the ratio of the Electricity production(% of total) in 1962 in Luxembourg to that in Norway?
Keep it short and to the point. 0.03. What is the ratio of the Electricity production(% of total) of 1963 in Luxembourg to that in Norway?
Your response must be concise. 0. What is the ratio of the Electricity production(% of total) of 1960 in Luxembourg to that in Poland?
Ensure brevity in your answer.  0.63. What is the ratio of the Electricity production(% of total) of 1961 in Luxembourg to that in Poland?
Provide a succinct answer. 1.99. What is the ratio of the Electricity production(% of total) of 1962 in Luxembourg to that in Poland?
Ensure brevity in your answer.  1.45. What is the ratio of the Electricity production(% of total) in 1963 in Luxembourg to that in Poland?
Your answer should be compact. 0.08. What is the ratio of the Electricity production(% of total) in 1960 in New Zealand to that in Norway?
Provide a short and direct response. 0.8. What is the ratio of the Electricity production(% of total) in 1961 in New Zealand to that in Norway?
Give a very brief answer. 0.8. What is the ratio of the Electricity production(% of total) of 1962 in New Zealand to that in Norway?
Provide a short and direct response. 0.85. What is the ratio of the Electricity production(% of total) in 1963 in New Zealand to that in Norway?
Give a very brief answer. 0.76. What is the ratio of the Electricity production(% of total) of 1960 in New Zealand to that in Poland?
Make the answer very short. 36.95. What is the ratio of the Electricity production(% of total) of 1961 in New Zealand to that in Poland?
Your answer should be compact. 42.37. What is the ratio of the Electricity production(% of total) of 1962 in New Zealand to that in Poland?
Your answer should be very brief. 39.6. What is the ratio of the Electricity production(% of total) of 1963 in New Zealand to that in Poland?
Keep it short and to the point. 43.2. What is the ratio of the Electricity production(% of total) of 1960 in Norway to that in Poland?
Offer a very short reply. 46.01. What is the ratio of the Electricity production(% of total) of 1961 in Norway to that in Poland?
Provide a short and direct response. 53.03. What is the ratio of the Electricity production(% of total) in 1962 in Norway to that in Poland?
Offer a terse response. 46.75. What is the ratio of the Electricity production(% of total) of 1963 in Norway to that in Poland?
Provide a short and direct response. 56.8. What is the difference between the highest and the second highest Electricity production(% of total) of 1961?
Give a very brief answer. 19.97. What is the difference between the highest and the second highest Electricity production(% of total) in 1962?
Keep it short and to the point. 15.23. What is the difference between the highest and the second highest Electricity production(% of total) of 1963?
Offer a very short reply. 23.82. What is the difference between the highest and the lowest Electricity production(% of total) in 1960?
Make the answer very short. 97.93. What is the difference between the highest and the lowest Electricity production(% of total) of 1961?
Ensure brevity in your answer.  97.47. What is the difference between the highest and the lowest Electricity production(% of total) in 1962?
Keep it short and to the point. 97.54. What is the difference between the highest and the lowest Electricity production(% of total) of 1963?
Keep it short and to the point. 99.33. 